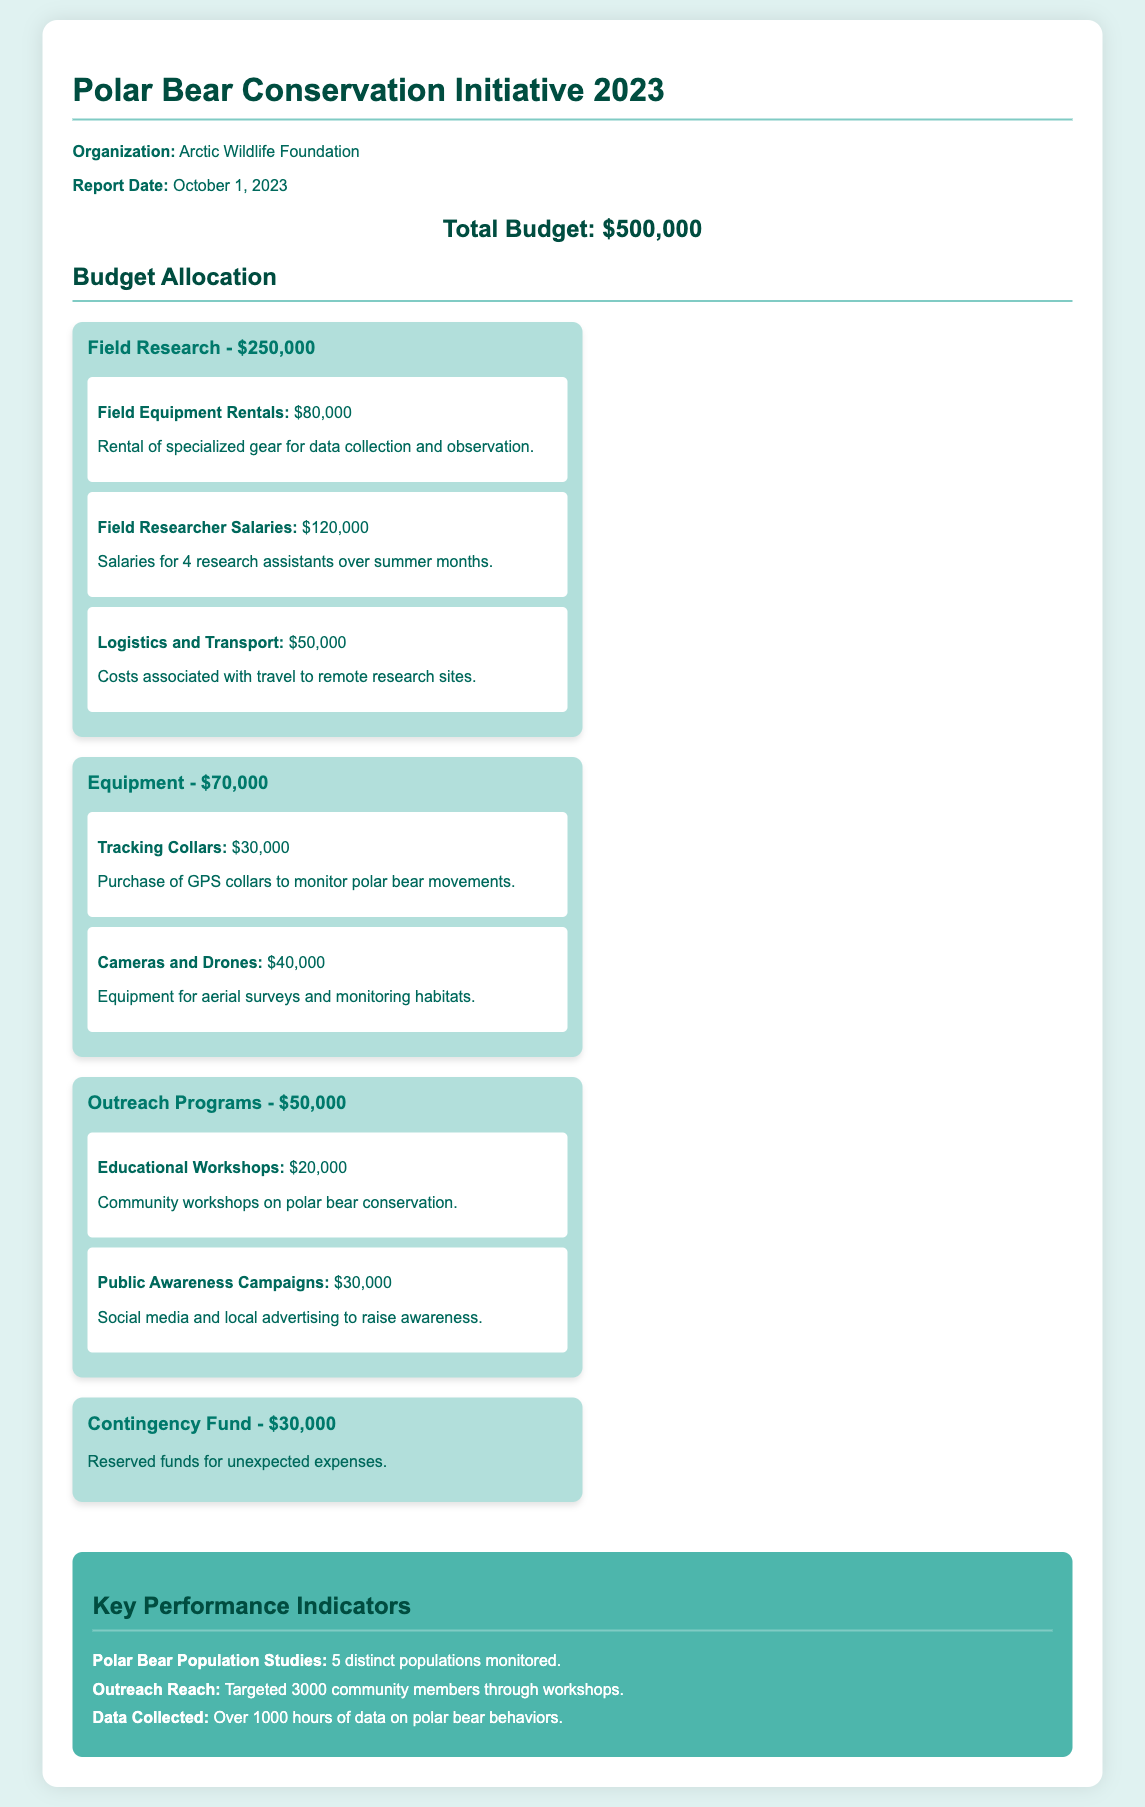What is the total budget? The total budget is explicitly stated in the document as the overall financial allocation for the project.
Answer: $500,000 How much is allocated for field research? The field research section details its specific budget allocation, which is prominently displayed.
Answer: $250,000 What is the cost of tracking collars? The document provides specific figures for the costs associated with different equipment, including tracking collars.
Answer: $30,000 How many community members were targeted through outreach? This information relates to the performance indicators section, which lists the outreach achievement.
Answer: 3000 What is the amount reserved for the contingency fund? The contingency fund is mentioned in a specific budget category, including its designated amount.
Answer: $30,000 How many polarization populations are being monitored? The key performance indicators section presents statistical data about the monitored polar bear populations.
Answer: 5 distinct populations What is the budget for educational workshops? The outreach programs section specifies how much funding is allocated for educational workshops.
Answer: $20,000 What is the total cost for equipment purchases? This question combines the costs of different equipment-related budget categories outlined in the document.
Answer: $70,000 What are the two main components of the logistics and transport budget? The explanation can be derived from the field research budget category outlining transport-related costs.
Answer: Travel to remote research sites 